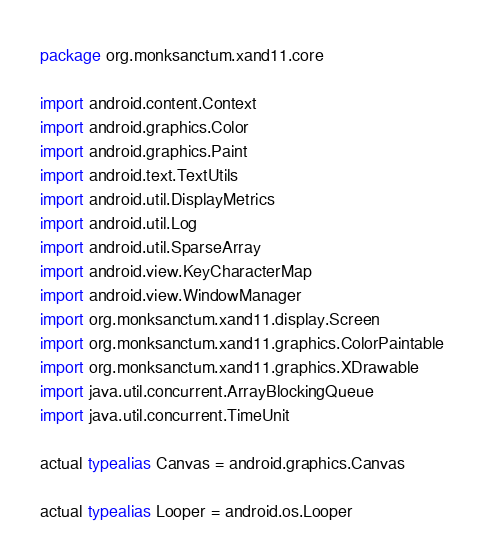<code> <loc_0><loc_0><loc_500><loc_500><_Kotlin_>package org.monksanctum.xand11.core

import android.content.Context
import android.graphics.Color
import android.graphics.Paint
import android.text.TextUtils
import android.util.DisplayMetrics
import android.util.Log
import android.util.SparseArray
import android.view.KeyCharacterMap
import android.view.WindowManager
import org.monksanctum.xand11.display.Screen
import org.monksanctum.xand11.graphics.ColorPaintable
import org.monksanctum.xand11.graphics.XDrawable
import java.util.concurrent.ArrayBlockingQueue
import java.util.concurrent.TimeUnit

actual typealias Canvas = android.graphics.Canvas

actual typealias Looper = android.os.Looper</code> 